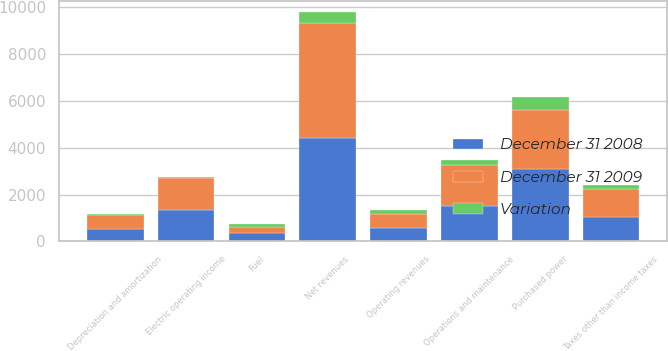<chart> <loc_0><loc_0><loc_500><loc_500><stacked_bar_chart><ecel><fcel>Operating revenues<fcel>Purchased power<fcel>Fuel<fcel>Net revenues<fcel>Operations and maintenance<fcel>Depreciation and amortization<fcel>Taxes other than income taxes<fcel>Electric operating income<nl><fcel>December 31 2009<fcel>575<fcel>2529<fcel>247<fcel>4898<fcel>1734<fcel>587<fcel>1209<fcel>1368<nl><fcel>December 31 2008<fcel>575<fcel>3092<fcel>376<fcel>4410<fcel>1518<fcel>521<fcel>1038<fcel>1333<nl><fcel>Variation<fcel>204<fcel>563<fcel>129<fcel>488<fcel>216<fcel>66<fcel>171<fcel>35<nl></chart> 